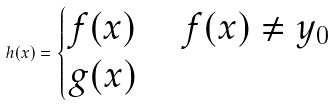Convert formula to latex. <formula><loc_0><loc_0><loc_500><loc_500>h ( x ) = \begin{cases} f ( x ) & \ f ( x ) \neq y _ { 0 } \\ g ( x ) & \end{cases}</formula> 